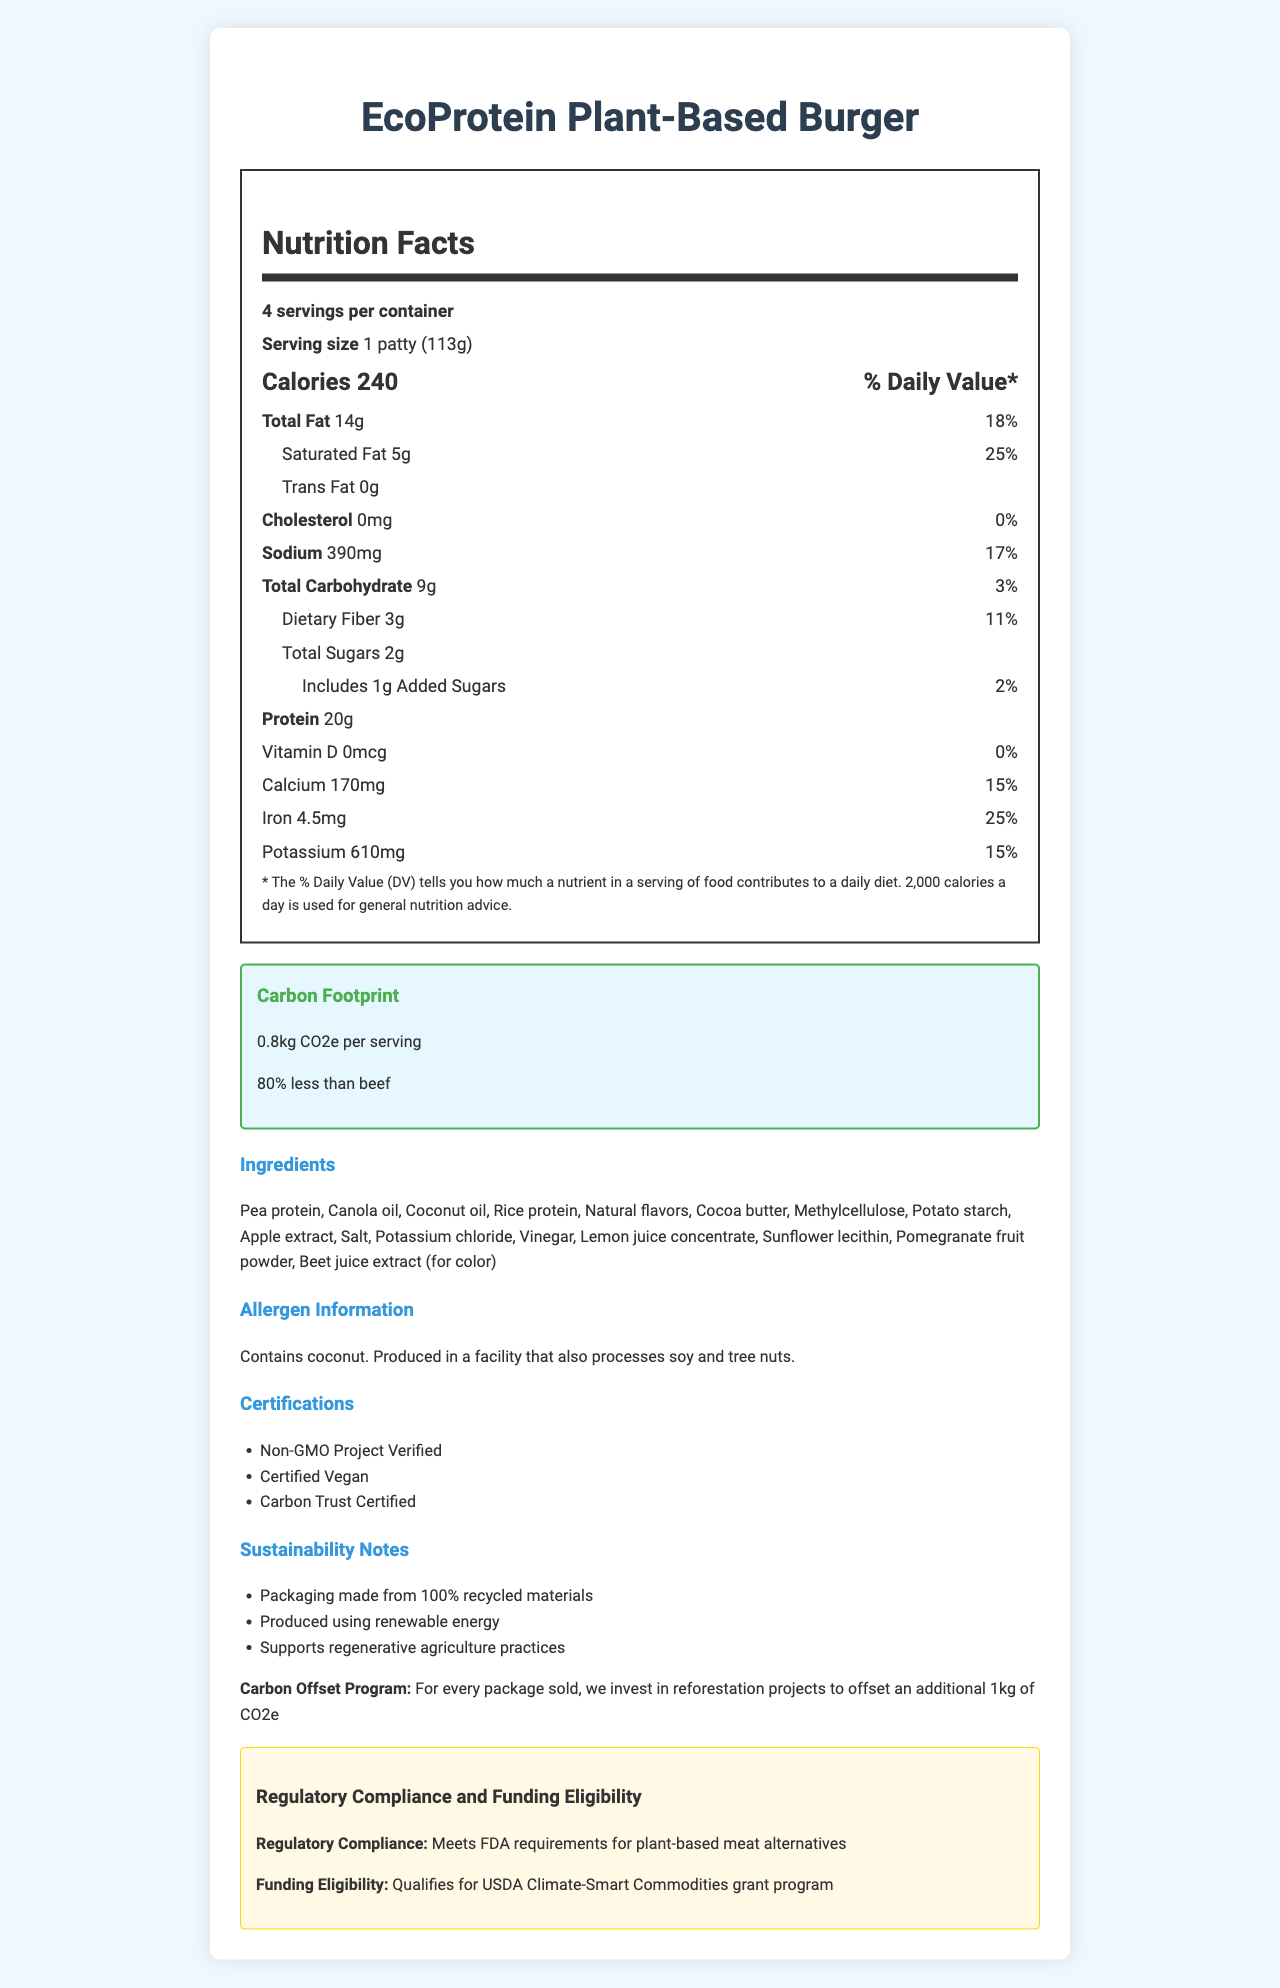What is the serving size for the EcoProtein Plant-Based Burger? The document states the serving size explicitly as "1 patty (113g)".
Answer: 1 patty (113g) How many calories are there per serving? The document lists the number of calories per serving as "240".
Answer: 240 What is the amount of protein per serving? The nutritional facts section shows the amount of protein per serving as "20g".
Answer: 20g How much saturated fat does a serving contain? The document lists the amount of saturated fat at "5g".
Answer: 5g What is the carbon footprint per serving? The carbon footprint section of the document states "0.8kg CO2e per serving".
Answer: 0.8kg CO2e What certifications does the product have? A. Non-GMO Project Verified B. Certified Vegan C. Carbon Trust Certified D. All of the above The document lists the certifications as "Non-GMO Project Verified", "Certified Vegan", and "Carbon Trust Certified", implying all of the above.
Answer: D What percent less carbon footprint does the EcoProtein Plant-Based Burger have compared to beef? The document states that the product has "80% less" carbon footprint compared to beef.
Answer: 80% Is this product suitable for someone with a tree nut allergy? The allergen information states that the product is "Produced in a facility that also processes soy and tree nuts," which may not be safe for someone with a tree nut allergy.
Answer: No What are the main ingredients in the EcoProtein Plant-Based Burger? The ingredients list starts with these main components.
Answer: Pea protein, Canola oil, Coconut oil, Rice protein What sustainability practices does the company claim to follow? The sustainability notes section lists these practices.
Answer: Packaging made from 100% recycled materials, produced using renewable energy, supports regenerative agriculture practices How many servings are there per container? The document clearly states that there are "4 servings per container".
Answer: 4 What program does the product qualify for in terms of funding eligibility? A. USDA Climate-Smart Commodities grant program B. FDA Food Safety Modernization Act C. EPA Greenhouse Gas Reporting Program The document mentions that the product qualifies for the "USDA Climate-Smart Commodities grant program".
Answer: A What is the added sugar content per serving? The document lists "Includes 1g Added Sugars".
Answer: 1g Does the product contain any cholesterol? The cholesterol content is listed as "0mg", and the daily value percentage is "0%".
Answer: No What allergen is explicitly listed as contained in the product? The allergen information notes, "Contains coconut".
Answer: Coconut How do the sustainability notes describe the product's packaging? The sustainability notes specifically mention that the packaging is "made from 100% recycled materials".
Answer: Made from 100% recycled materials Summarize the main features of the EcoProtein Plant-Based Burger based on the document. The document provides detailed information about the product's nutritional content, carbon footprint, ingredients, allergens, certifications, sustainability practices, and funding eligibility.
Answer: The EcoProtein Plant-Based Burger is a plant-based meat alternative with significant sustainability features, including a low carbon footprint (0.8kg CO2e, 80% less than beef), recyclable packaging, and renewable energy usage. It contains 240 calories, 20g of protein, and 14g of total fat per serving. The product is certified by the Non-GMO Project, Certified Vegan, and Carbon Trust. It qualifies for the USDA Climate-Smart Commodities grant program. The allergen information includes coconut, and it may be processed in a facility with soy and tree nuts. What is the percentage RDA for sodium in one serving? The document lists sodium with a daily value percentage of "17%".
Answer: 17% What is the total fiber content per serving? The nutritional facts section shows the dietary fiber content as "3g".
Answer: 3g What is the cholesterol level in the EcoProtein Plant-Based Burger compared to a typical beef burger? The document provides the cholesterol content for the EcoProtein Plant-Based Burger as "0mg" but does not provide information about the cholesterol content in a typical beef burger to make a comparison.
Answer: Not enough information 